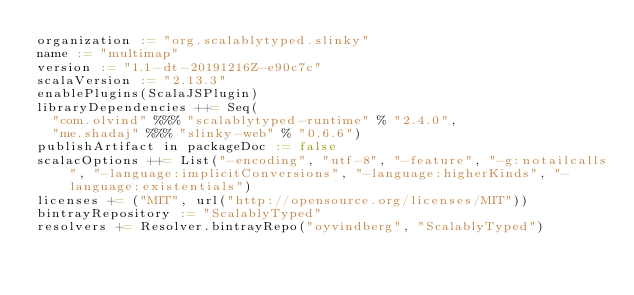Convert code to text. <code><loc_0><loc_0><loc_500><loc_500><_Scala_>organization := "org.scalablytyped.slinky"
name := "multimap"
version := "1.1-dt-20191216Z-e90c7c"
scalaVersion := "2.13.3"
enablePlugins(ScalaJSPlugin)
libraryDependencies ++= Seq(
  "com.olvind" %%% "scalablytyped-runtime" % "2.4.0",
  "me.shadaj" %%% "slinky-web" % "0.6.6")
publishArtifact in packageDoc := false
scalacOptions ++= List("-encoding", "utf-8", "-feature", "-g:notailcalls", "-language:implicitConversions", "-language:higherKinds", "-language:existentials")
licenses += ("MIT", url("http://opensource.org/licenses/MIT"))
bintrayRepository := "ScalablyTyped"
resolvers += Resolver.bintrayRepo("oyvindberg", "ScalablyTyped")
</code> 